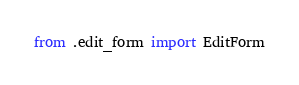Convert code to text. <code><loc_0><loc_0><loc_500><loc_500><_Python_>from .edit_form import EditForm
</code> 